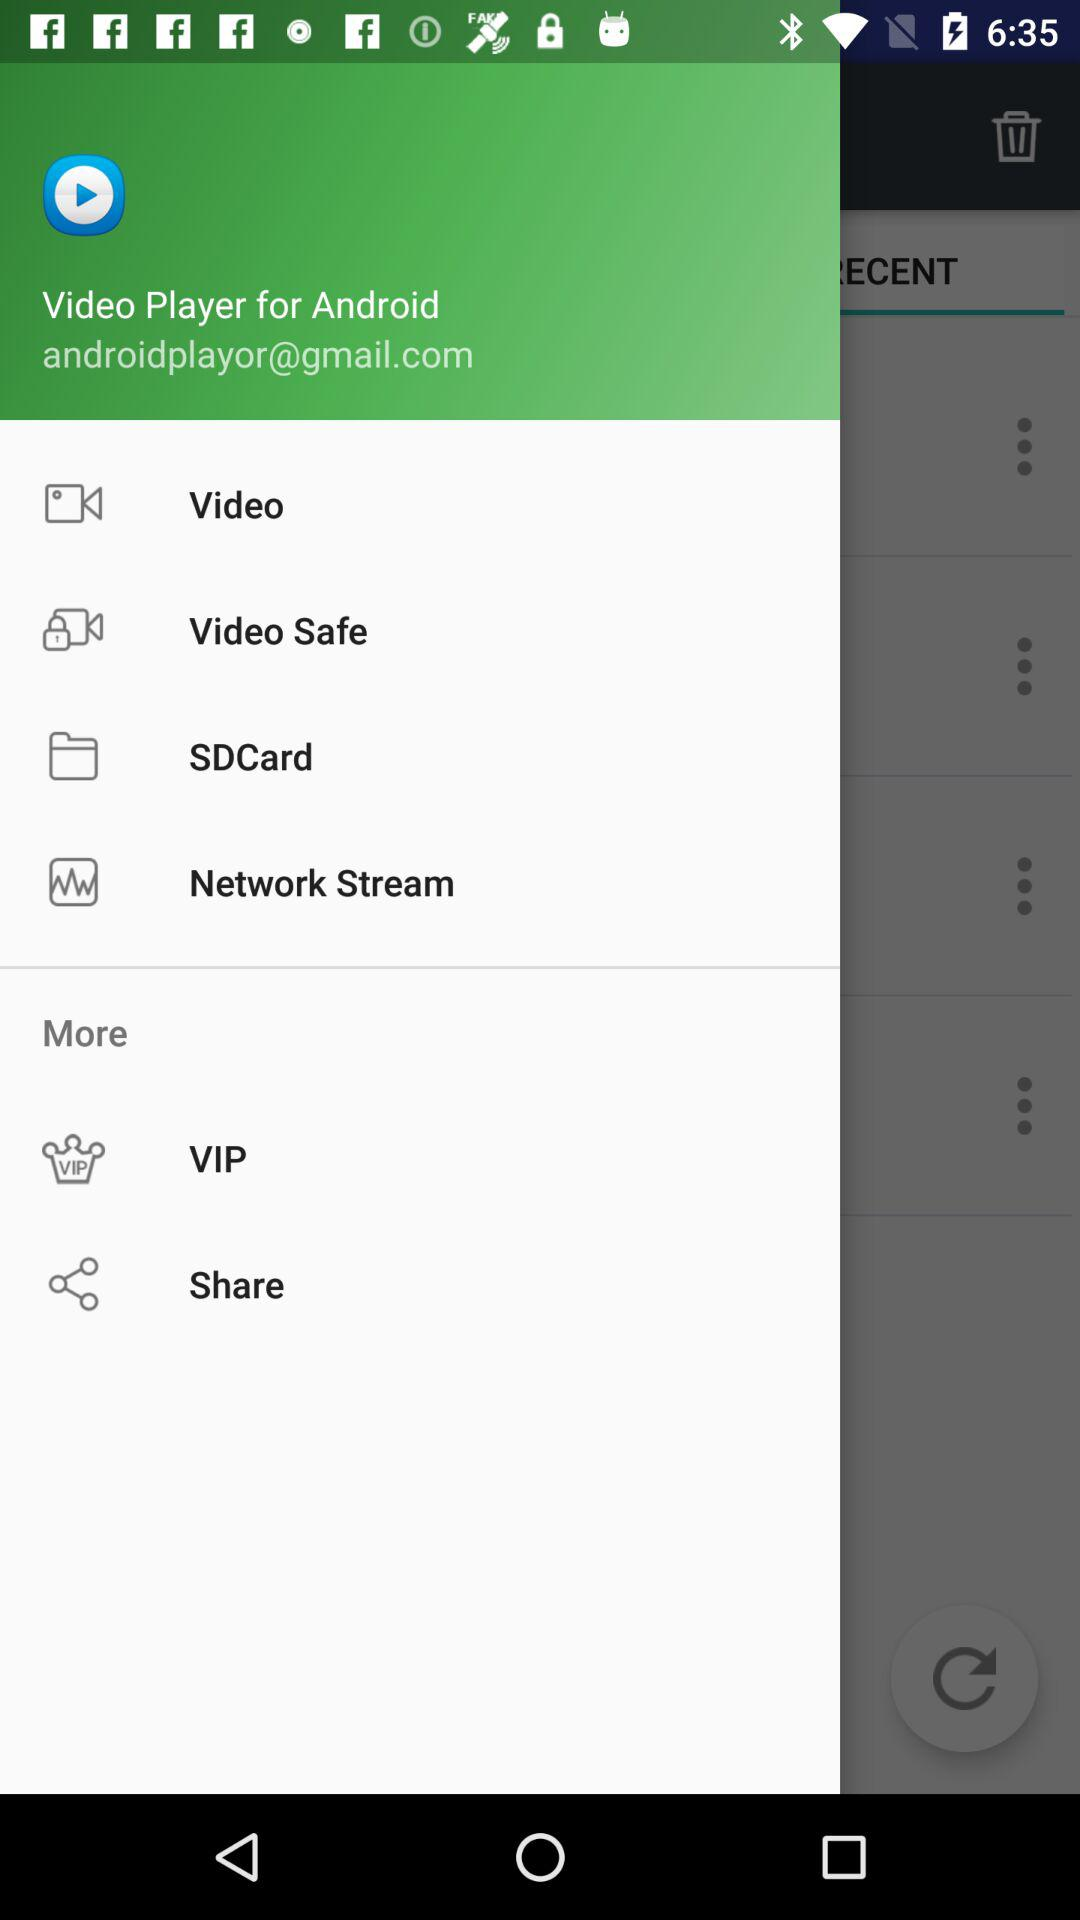How many items have the text 'Video'?
Answer the question using a single word or phrase. 2 